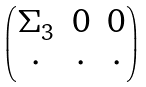Convert formula to latex. <formula><loc_0><loc_0><loc_500><loc_500>\begin{pmatrix} \Sigma _ { 3 } & 0 & 0 \\ \cdot & \cdot & \cdot \end{pmatrix}</formula> 